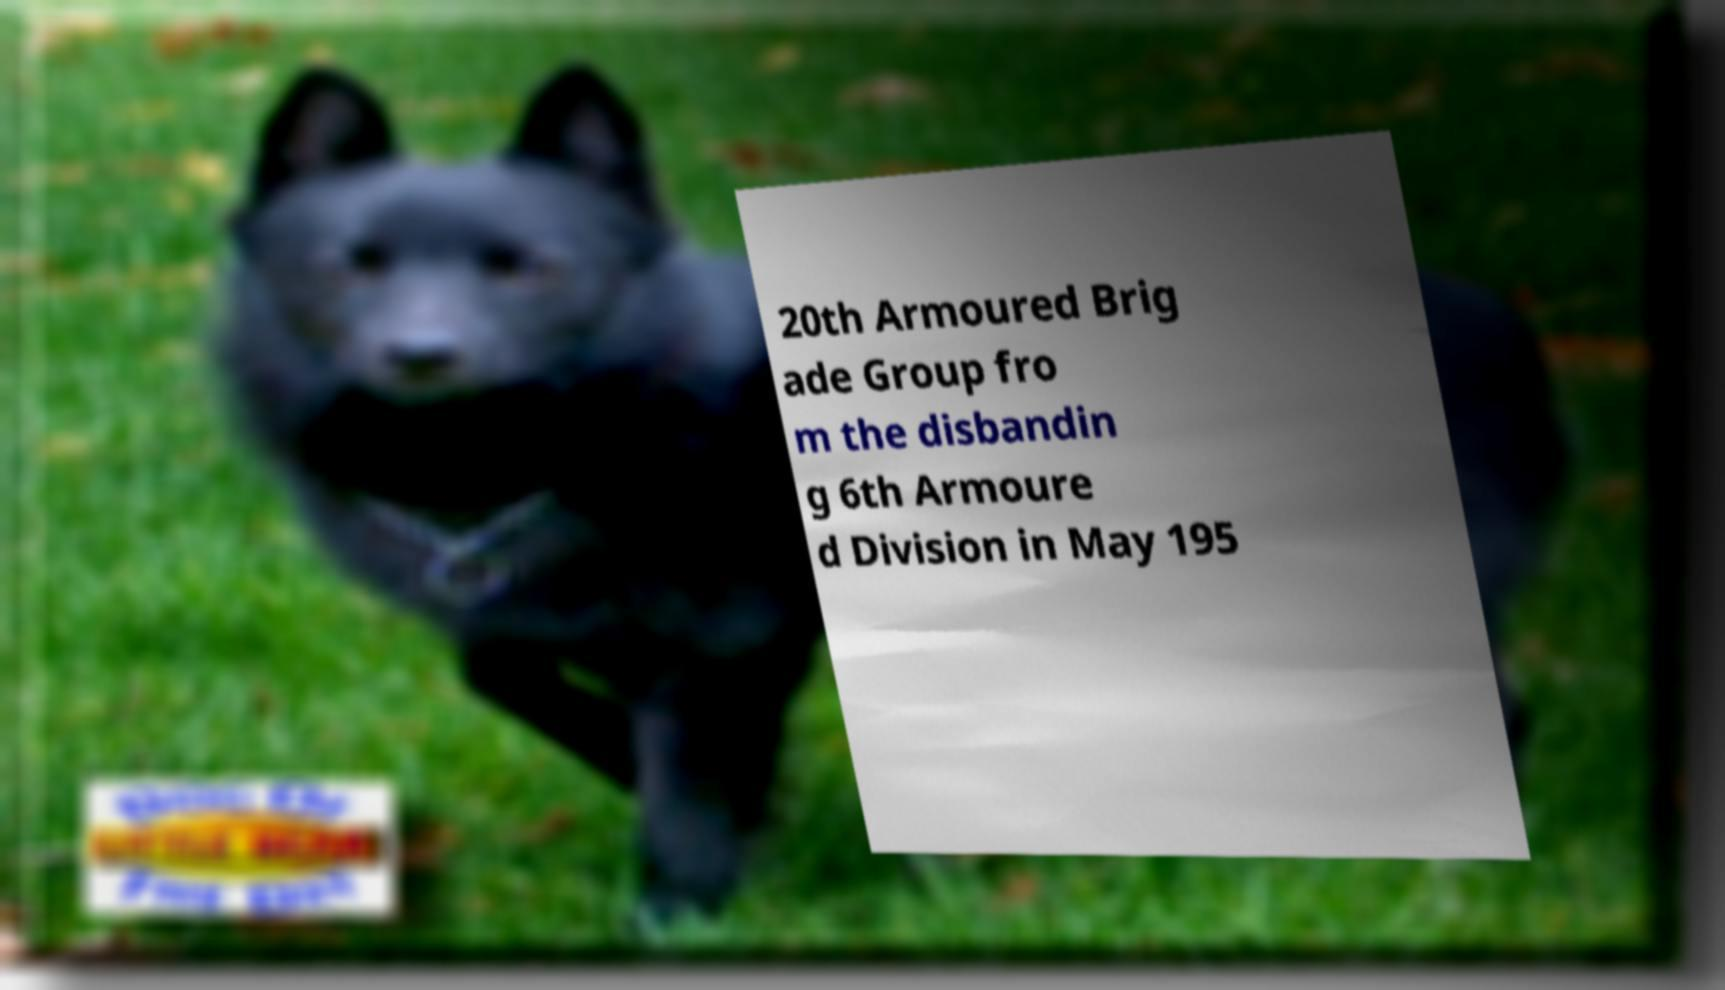Can you read and provide the text displayed in the image?This photo seems to have some interesting text. Can you extract and type it out for me? 20th Armoured Brig ade Group fro m the disbandin g 6th Armoure d Division in May 195 